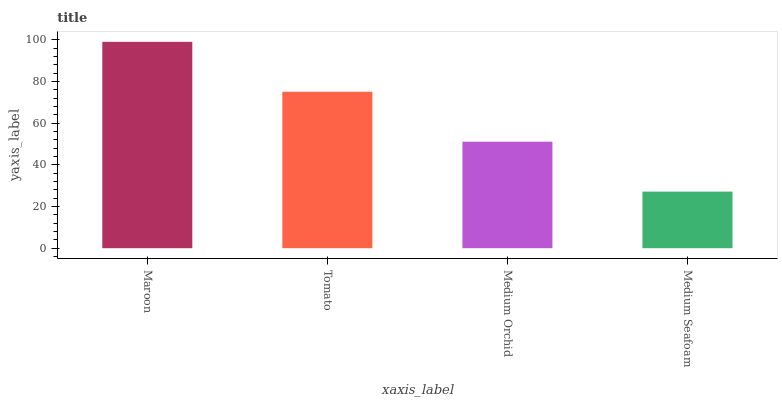Is Medium Seafoam the minimum?
Answer yes or no. Yes. Is Maroon the maximum?
Answer yes or no. Yes. Is Tomato the minimum?
Answer yes or no. No. Is Tomato the maximum?
Answer yes or no. No. Is Maroon greater than Tomato?
Answer yes or no. Yes. Is Tomato less than Maroon?
Answer yes or no. Yes. Is Tomato greater than Maroon?
Answer yes or no. No. Is Maroon less than Tomato?
Answer yes or no. No. Is Tomato the high median?
Answer yes or no. Yes. Is Medium Orchid the low median?
Answer yes or no. Yes. Is Maroon the high median?
Answer yes or no. No. Is Tomato the low median?
Answer yes or no. No. 